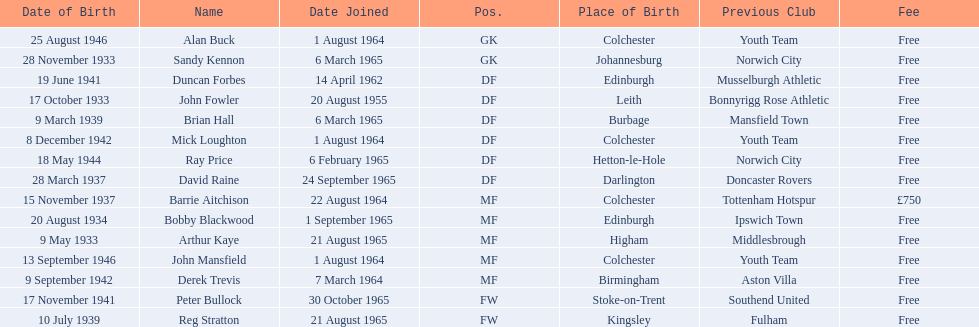Who are all the players? Alan Buck, Sandy Kennon, Duncan Forbes, John Fowler, Brian Hall, Mick Loughton, Ray Price, David Raine, Barrie Aitchison, Bobby Blackwood, Arthur Kaye, John Mansfield, Derek Trevis, Peter Bullock, Reg Stratton. What dates did the players join on? 1 August 1964, 6 March 1965, 14 April 1962, 20 August 1955, 6 March 1965, 1 August 1964, 6 February 1965, 24 September 1965, 22 August 1964, 1 September 1965, 21 August 1965, 1 August 1964, 7 March 1964, 30 October 1965, 21 August 1965. Who is the first player who joined? John Fowler. What is the date of the first person who joined? 20 August 1955. 